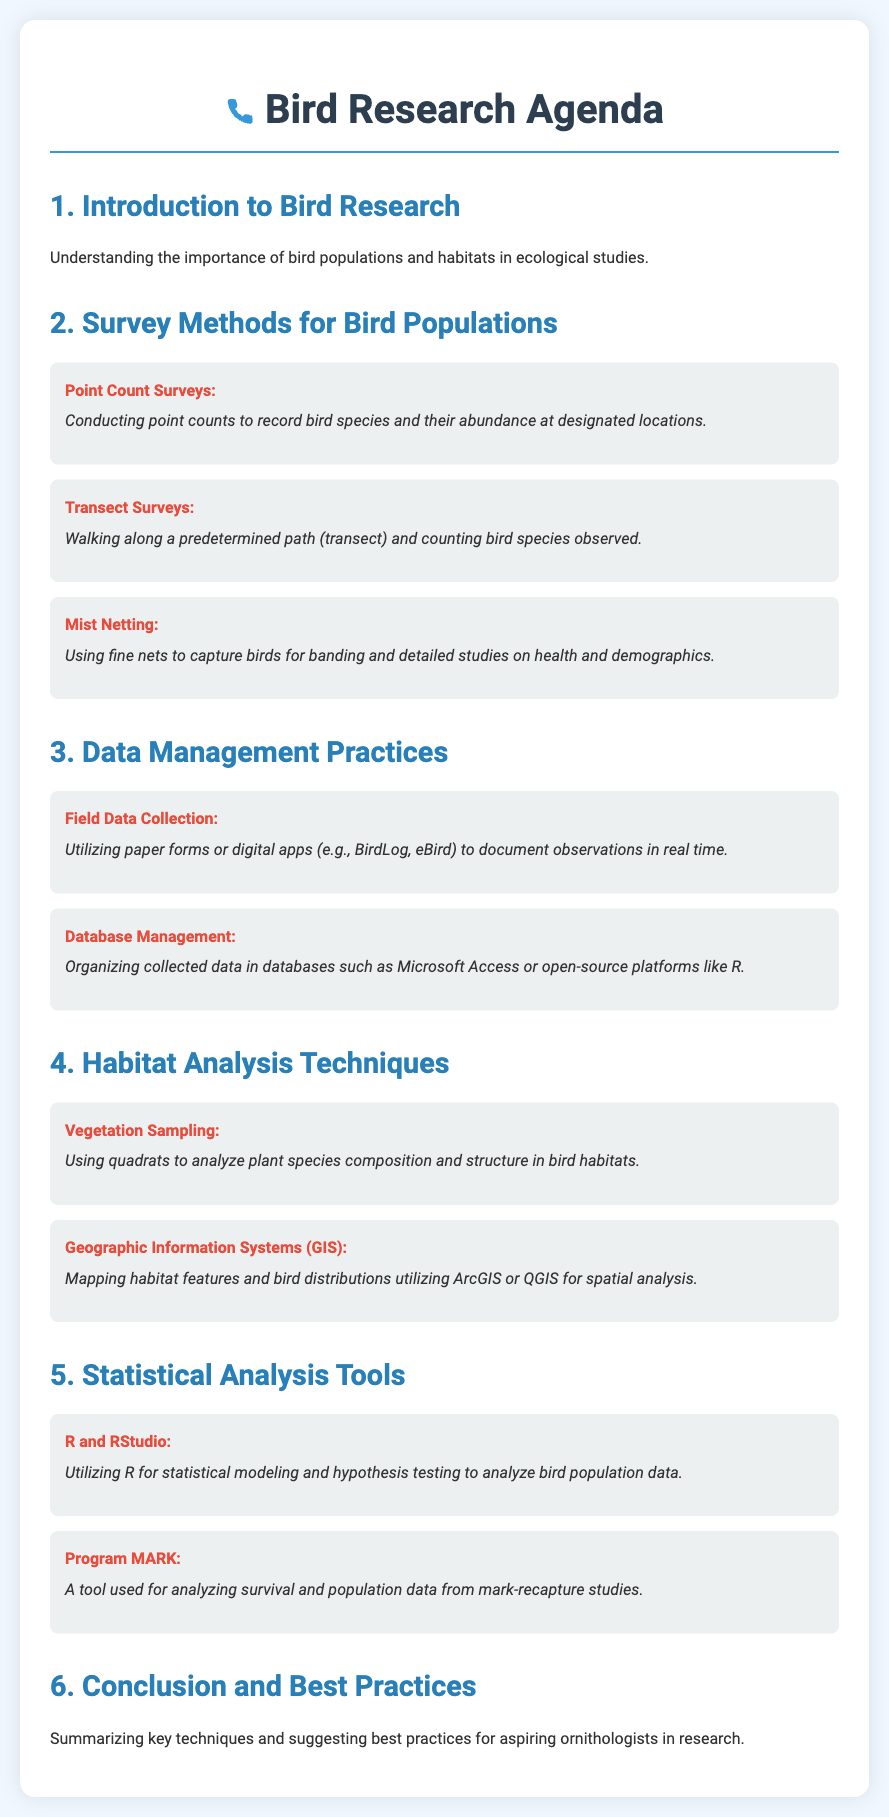what is the first section of the agenda? The first section introduces the importance of bird populations and habitats in ecological studies.
Answer: Introduction to Bird Research how many survey methods are listed in the document? The document lists three survey methods for bird populations.
Answer: 3 what is a method used to capture birds for banding? The method described for capturing birds is mist netting.
Answer: Mist Netting which tool is mentioned for analyzing survival and population data? The document mentions Program MARK as a tool for analyzing survival and population data.
Answer: Program MARK what are the two types of data management practices described? The two practices described are field data collection and database management.
Answer: Field Data Collection, Database Management name one geographic information system mentioned in the document. The document mentions ArcGIS as one of the geographic information systems.
Answer: ArcGIS what is the technique used for vegetation sampling? The technique used for vegetation sampling is using quadrats.
Answer: Vegetation Sampling what concludes the agenda? The agenda concludes with a summary of key techniques and best practices for aspiring ornithologists.
Answer: Conclusion and Best Practices 